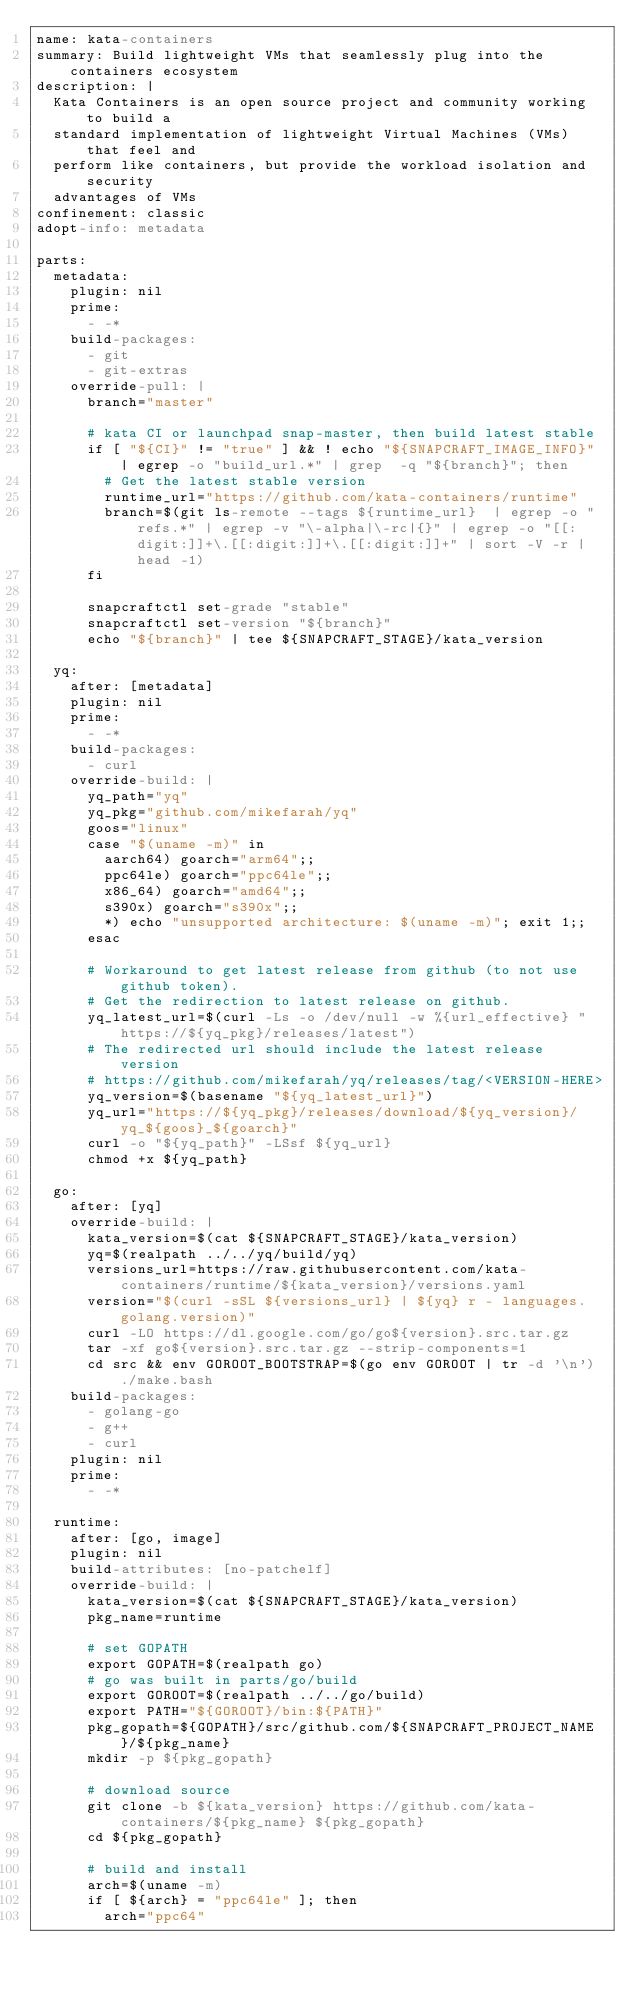<code> <loc_0><loc_0><loc_500><loc_500><_YAML_>name: kata-containers
summary: Build lightweight VMs that seamlessly plug into the containers ecosystem
description: |
  Kata Containers is an open source project and community working to build a
  standard implementation of lightweight Virtual Machines (VMs) that feel and
  perform like containers, but provide the workload isolation and security
  advantages of VMs
confinement: classic
adopt-info: metadata

parts:
  metadata:
    plugin: nil
    prime:
      - -*
    build-packages:
      - git
      - git-extras
    override-pull: |
      branch="master"

      # kata CI or launchpad snap-master, then build latest stable
      if [ "${CI}" != "true" ] && ! echo "${SNAPCRAFT_IMAGE_INFO}" | egrep -o "build_url.*" | grep  -q "${branch}"; then
        # Get the latest stable version
        runtime_url="https://github.com/kata-containers/runtime"
        branch=$(git ls-remote --tags ${runtime_url}  | egrep -o "refs.*" | egrep -v "\-alpha|\-rc|{}" | egrep -o "[[:digit:]]+\.[[:digit:]]+\.[[:digit:]]+" | sort -V -r | head -1)
      fi

      snapcraftctl set-grade "stable"
      snapcraftctl set-version "${branch}"
      echo "${branch}" | tee ${SNAPCRAFT_STAGE}/kata_version

  yq:
    after: [metadata]
    plugin: nil
    prime:
      - -*
    build-packages:
      - curl
    override-build: |
      yq_path="yq"
      yq_pkg="github.com/mikefarah/yq"
      goos="linux"
      case "$(uname -m)" in
        aarch64) goarch="arm64";;
        ppc64le) goarch="ppc64le";;
        x86_64) goarch="amd64";;
        s390x) goarch="s390x";;
        *) echo "unsupported architecture: $(uname -m)"; exit 1;;
      esac

      # Workaround to get latest release from github (to not use github token).
      # Get the redirection to latest release on github.
      yq_latest_url=$(curl -Ls -o /dev/null -w %{url_effective} "https://${yq_pkg}/releases/latest")
      # The redirected url should include the latest release version
      # https://github.com/mikefarah/yq/releases/tag/<VERSION-HERE>
      yq_version=$(basename "${yq_latest_url}")
      yq_url="https://${yq_pkg}/releases/download/${yq_version}/yq_${goos}_${goarch}"
      curl -o "${yq_path}" -LSsf ${yq_url}
      chmod +x ${yq_path}

  go:
    after: [yq]
    override-build: |
      kata_version=$(cat ${SNAPCRAFT_STAGE}/kata_version)
      yq=$(realpath ../../yq/build/yq)
      versions_url=https://raw.githubusercontent.com/kata-containers/runtime/${kata_version}/versions.yaml
      version="$(curl -sSL ${versions_url} | ${yq} r - languages.golang.version)"
      curl -LO https://dl.google.com/go/go${version}.src.tar.gz
      tar -xf go${version}.src.tar.gz --strip-components=1
      cd src && env GOROOT_BOOTSTRAP=$(go env GOROOT | tr -d '\n') ./make.bash
    build-packages:
      - golang-go
      - g++
      - curl
    plugin: nil
    prime:
      - -*

  runtime:
    after: [go, image]
    plugin: nil
    build-attributes: [no-patchelf]
    override-build: |
      kata_version=$(cat ${SNAPCRAFT_STAGE}/kata_version)
      pkg_name=runtime

      # set GOPATH
      export GOPATH=$(realpath go)
      # go was built in parts/go/build
      export GOROOT=$(realpath ../../go/build)
      export PATH="${GOROOT}/bin:${PATH}"
      pkg_gopath=${GOPATH}/src/github.com/${SNAPCRAFT_PROJECT_NAME}/${pkg_name}
      mkdir -p ${pkg_gopath}

      # download source
      git clone -b ${kata_version} https://github.com/kata-containers/${pkg_name} ${pkg_gopath}
      cd ${pkg_gopath}

      # build and install
      arch=$(uname -m)
      if [ ${arch} = "ppc64le" ]; then
        arch="ppc64"</code> 